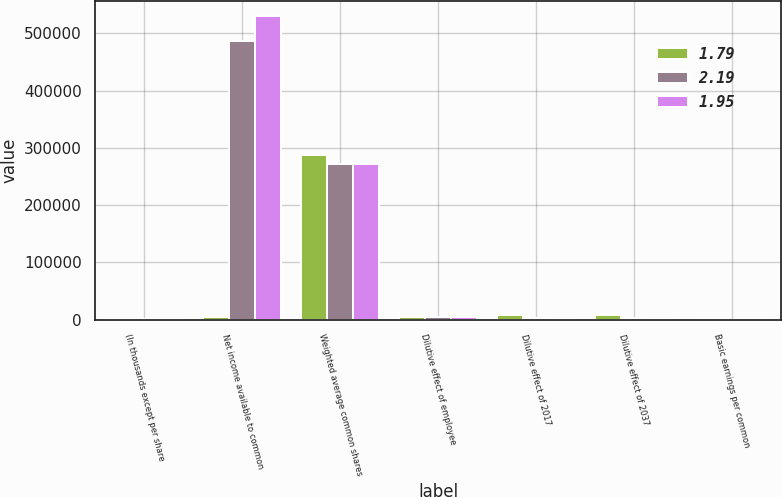<chart> <loc_0><loc_0><loc_500><loc_500><stacked_bar_chart><ecel><fcel>(In thousands except per share<fcel>Net income available to common<fcel>Weighted average common shares<fcel>Dilutive effect of employee<fcel>Dilutive effect of 2017<fcel>Dilutive effect of 2037<fcel>Basic earnings per common<nl><fcel>1.79<fcel>2014<fcel>4493<fcel>287396<fcel>4508<fcel>8544<fcel>7913<fcel>2.37<nl><fcel>2.19<fcel>2013<fcel>487536<fcel>272573<fcel>4146<fcel>2924<fcel>3851<fcel>1.86<nl><fcel>1.95<fcel>2012<fcel>530079<fcel>272157<fcel>4493<fcel>1708<fcel>2173<fcel>2.01<nl></chart> 